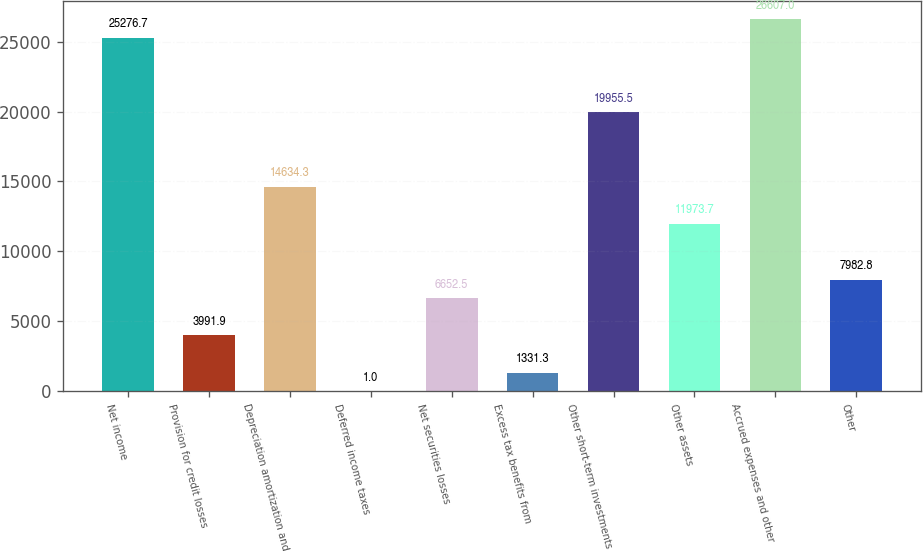Convert chart. <chart><loc_0><loc_0><loc_500><loc_500><bar_chart><fcel>Net income<fcel>Provision for credit losses<fcel>Depreciation amortization and<fcel>Deferred income taxes<fcel>Net securities losses<fcel>Excess tax benefits from<fcel>Other short-term investments<fcel>Other assets<fcel>Accrued expenses and other<fcel>Other<nl><fcel>25276.7<fcel>3991.9<fcel>14634.3<fcel>1<fcel>6652.5<fcel>1331.3<fcel>19955.5<fcel>11973.7<fcel>26607<fcel>7982.8<nl></chart> 